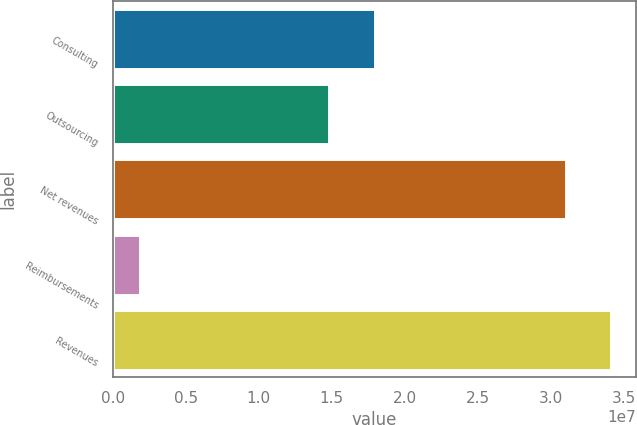<chart> <loc_0><loc_0><loc_500><loc_500><bar_chart><fcel>Consulting<fcel>Outsourcing<fcel>Net revenues<fcel>Reimbursements<fcel>Revenues<nl><fcel>1.79488e+07<fcel>1.4844e+07<fcel>3.10479e+07<fcel>1.86649e+06<fcel>3.41527e+07<nl></chart> 